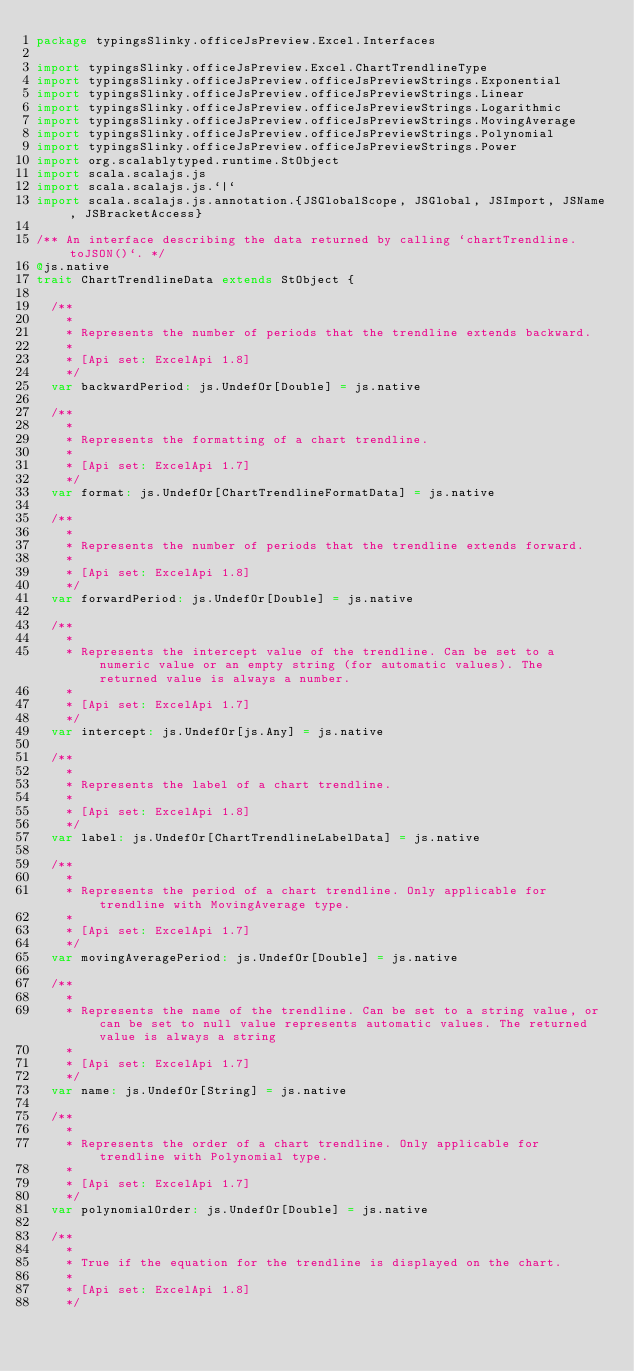Convert code to text. <code><loc_0><loc_0><loc_500><loc_500><_Scala_>package typingsSlinky.officeJsPreview.Excel.Interfaces

import typingsSlinky.officeJsPreview.Excel.ChartTrendlineType
import typingsSlinky.officeJsPreview.officeJsPreviewStrings.Exponential
import typingsSlinky.officeJsPreview.officeJsPreviewStrings.Linear
import typingsSlinky.officeJsPreview.officeJsPreviewStrings.Logarithmic
import typingsSlinky.officeJsPreview.officeJsPreviewStrings.MovingAverage
import typingsSlinky.officeJsPreview.officeJsPreviewStrings.Polynomial
import typingsSlinky.officeJsPreview.officeJsPreviewStrings.Power
import org.scalablytyped.runtime.StObject
import scala.scalajs.js
import scala.scalajs.js.`|`
import scala.scalajs.js.annotation.{JSGlobalScope, JSGlobal, JSImport, JSName, JSBracketAccess}

/** An interface describing the data returned by calling `chartTrendline.toJSON()`. */
@js.native
trait ChartTrendlineData extends StObject {
  
  /**
    *
    * Represents the number of periods that the trendline extends backward.
    *
    * [Api set: ExcelApi 1.8]
    */
  var backwardPeriod: js.UndefOr[Double] = js.native
  
  /**
    *
    * Represents the formatting of a chart trendline.
    *
    * [Api set: ExcelApi 1.7]
    */
  var format: js.UndefOr[ChartTrendlineFormatData] = js.native
  
  /**
    *
    * Represents the number of periods that the trendline extends forward.
    *
    * [Api set: ExcelApi 1.8]
    */
  var forwardPeriod: js.UndefOr[Double] = js.native
  
  /**
    *
    * Represents the intercept value of the trendline. Can be set to a numeric value or an empty string (for automatic values). The returned value is always a number.
    *
    * [Api set: ExcelApi 1.7]
    */
  var intercept: js.UndefOr[js.Any] = js.native
  
  /**
    *
    * Represents the label of a chart trendline.
    *
    * [Api set: ExcelApi 1.8]
    */
  var label: js.UndefOr[ChartTrendlineLabelData] = js.native
  
  /**
    *
    * Represents the period of a chart trendline. Only applicable for trendline with MovingAverage type.
    *
    * [Api set: ExcelApi 1.7]
    */
  var movingAveragePeriod: js.UndefOr[Double] = js.native
  
  /**
    *
    * Represents the name of the trendline. Can be set to a string value, or can be set to null value represents automatic values. The returned value is always a string
    *
    * [Api set: ExcelApi 1.7]
    */
  var name: js.UndefOr[String] = js.native
  
  /**
    *
    * Represents the order of a chart trendline. Only applicable for trendline with Polynomial type.
    *
    * [Api set: ExcelApi 1.7]
    */
  var polynomialOrder: js.UndefOr[Double] = js.native
  
  /**
    *
    * True if the equation for the trendline is displayed on the chart.
    *
    * [Api set: ExcelApi 1.8]
    */</code> 